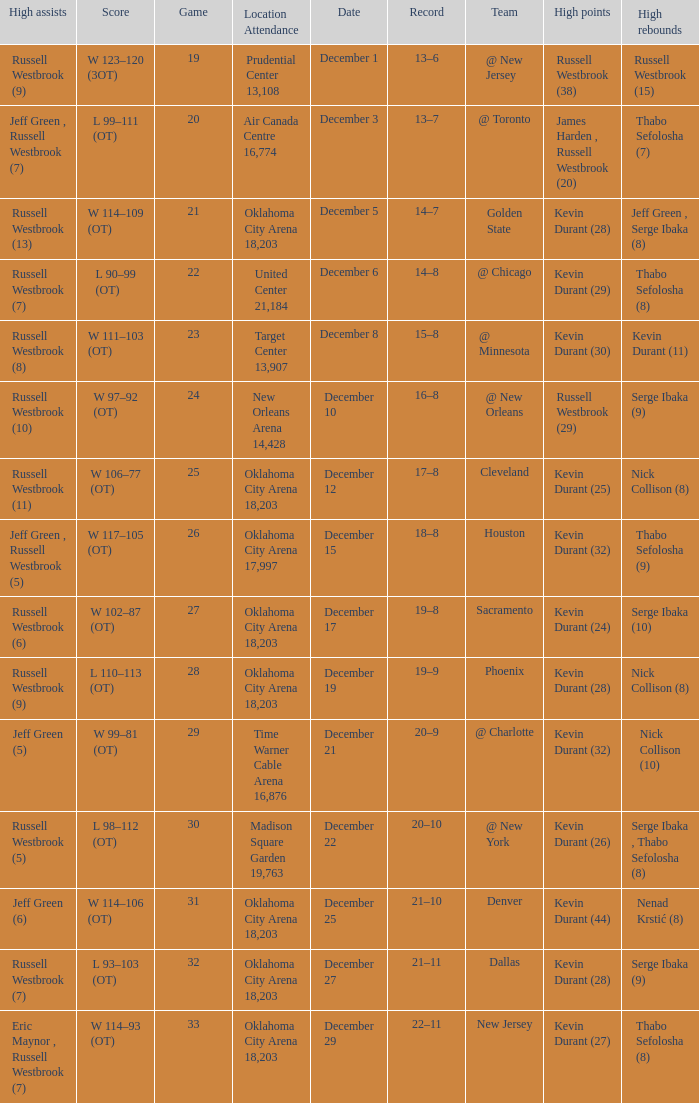Who had the high rebounds record on December 12? Nick Collison (8). 